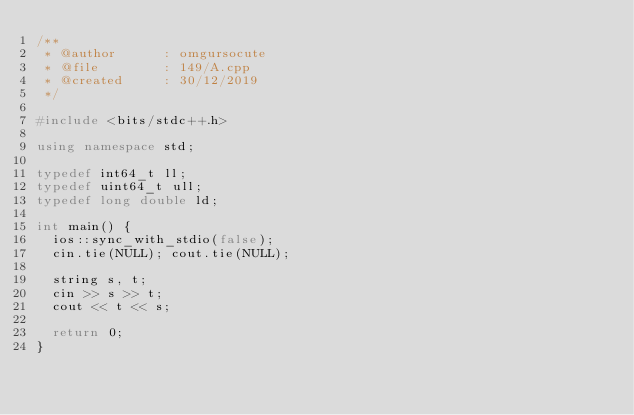<code> <loc_0><loc_0><loc_500><loc_500><_C++_>/**
 * @author      : omgursocute
 * @file        : 149/A.cpp
 * @created     : 30/12/2019
 */

#include <bits/stdc++.h>

using namespace std;

typedef int64_t ll;
typedef uint64_t ull;
typedef long double ld;

int main() {
	ios::sync_with_stdio(false);
	cin.tie(NULL); cout.tie(NULL);
	
	string s, t;
	cin >> s >> t;
	cout << t << s;
	
	return 0;
}

</code> 